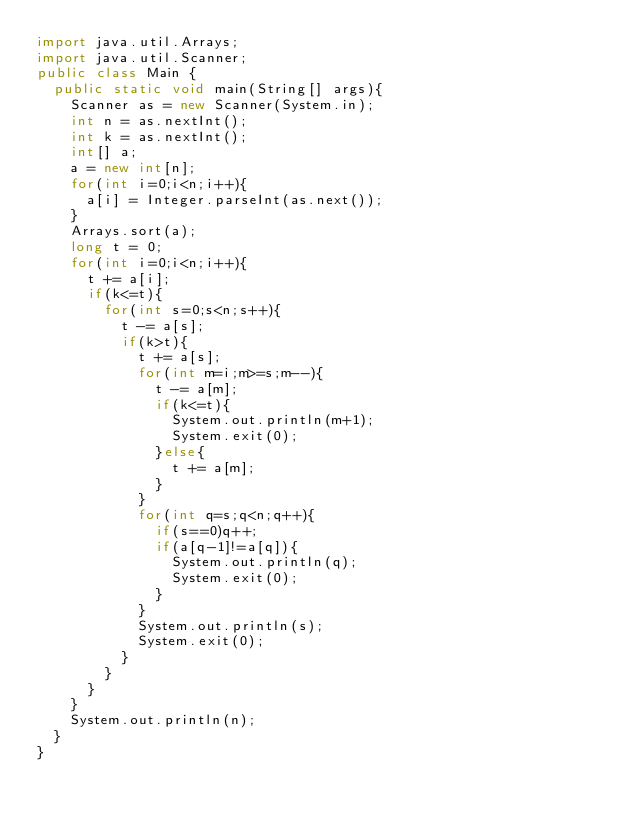<code> <loc_0><loc_0><loc_500><loc_500><_Java_>import java.util.Arrays;
import java.util.Scanner;
public class Main {
	public static void main(String[] args){
		Scanner as = new Scanner(System.in);
		int n = as.nextInt();
		int k = as.nextInt();
		int[] a;
		a = new int[n];
		for(int i=0;i<n;i++){
			a[i] = Integer.parseInt(as.next());
		}
		Arrays.sort(a); 
		long t = 0;
		for(int i=0;i<n;i++){
			t += a[i];
			if(k<=t){
				for(int s=0;s<n;s++){
					t -= a[s];
					if(k>t){
						t += a[s];
						for(int m=i;m>=s;m--){
							t -= a[m];
							if(k<=t){
								System.out.println(m+1);
								System.exit(0);
							}else{
								t += a[m];
							}
						}
						for(int q=s;q<n;q++){
							if(s==0)q++;
							if(a[q-1]!=a[q]){
								System.out.println(q);
								System.exit(0);
							}
						}
						System.out.println(s);
						System.exit(0);
					}
				}
			}
		}
		System.out.println(n);
	}
}</code> 